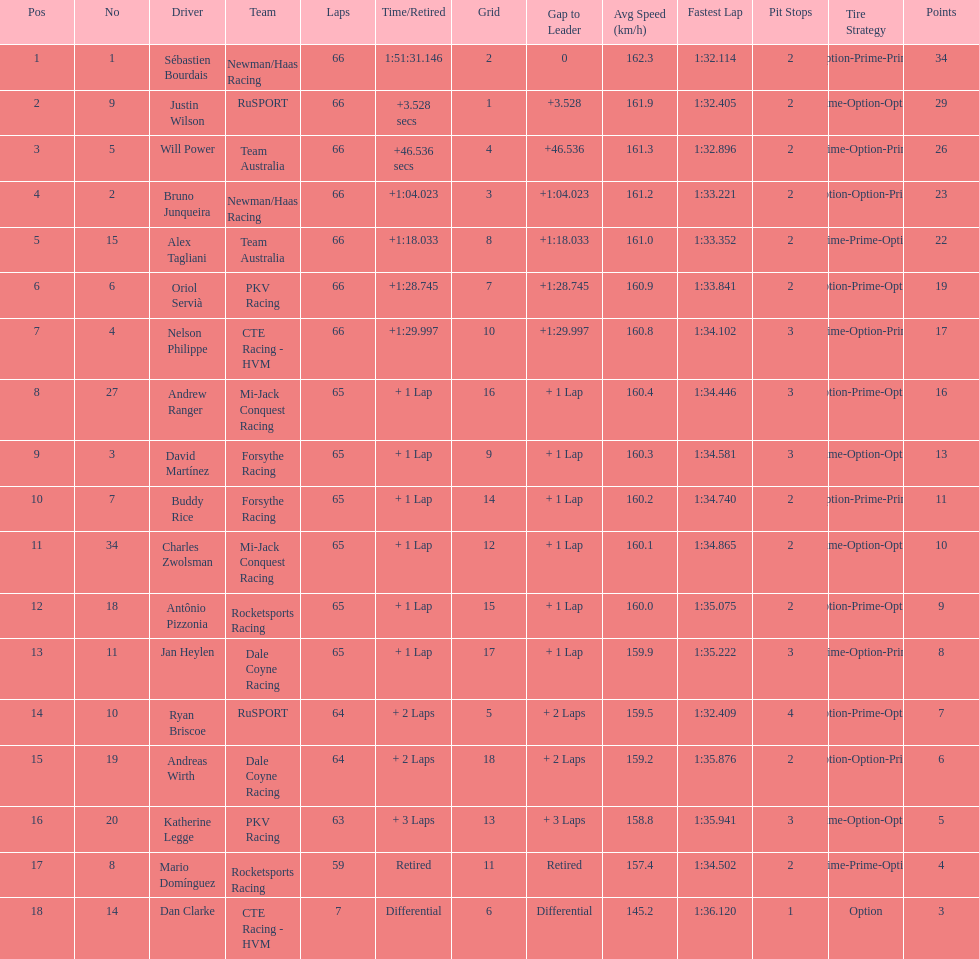What drivers started in the top 10? Sébastien Bourdais, Justin Wilson, Will Power, Bruno Junqueira, Alex Tagliani, Oriol Servià, Nelson Philippe, Ryan Briscoe, Dan Clarke. Which of those drivers completed all 66 laps? Sébastien Bourdais, Justin Wilson, Will Power, Bruno Junqueira, Alex Tagliani, Oriol Servià, Nelson Philippe. Whom of these did not drive for team australia? Sébastien Bourdais, Justin Wilson, Bruno Junqueira, Oriol Servià, Nelson Philippe. Which of these drivers finished more then a minuet after the winner? Bruno Junqueira, Oriol Servià, Nelson Philippe. Which of these drivers had the highest car number? Oriol Servià. 